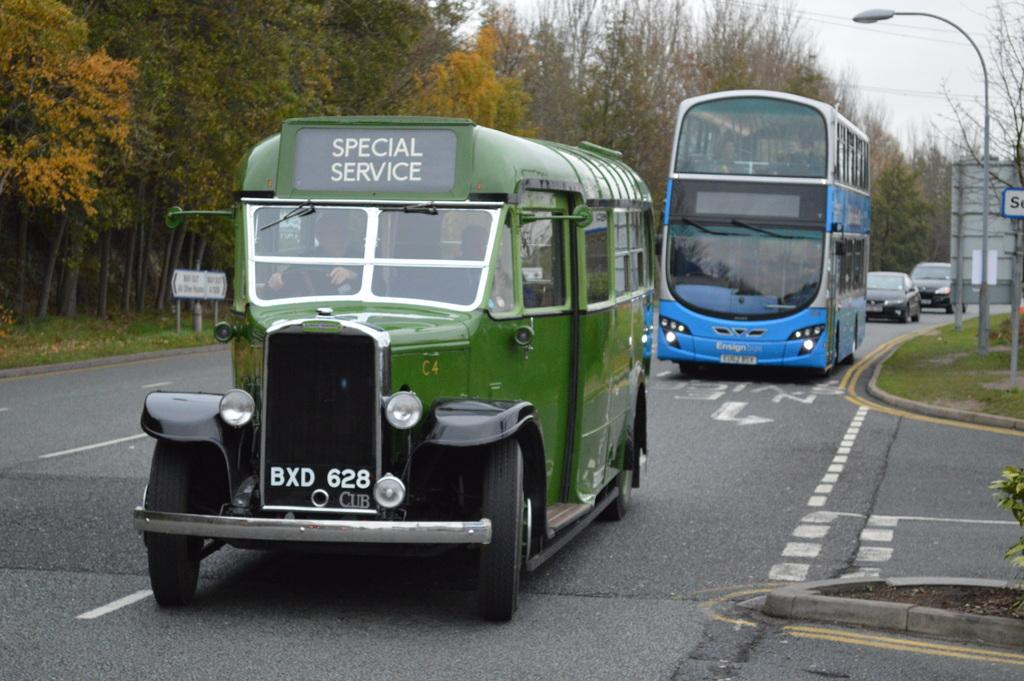What type of vehicle is in the image? There is a mini and a double-decker bus in the image. What else can be seen on the road in the image? There are cars on the road in the image. What type of vegetation is visible in the image? There are trees visible in the image. What is on the pole in the image? There is a hoarding board on a pole in the image. What is on the sidewalk in the image? There is a pole light on the sidewalk in the image. What type of plastic material is used to make the nation in the image? There is no mention of a nation or plastic material in the image; it features vehicles, cars, trees, a hoarding board, and a pole light. 